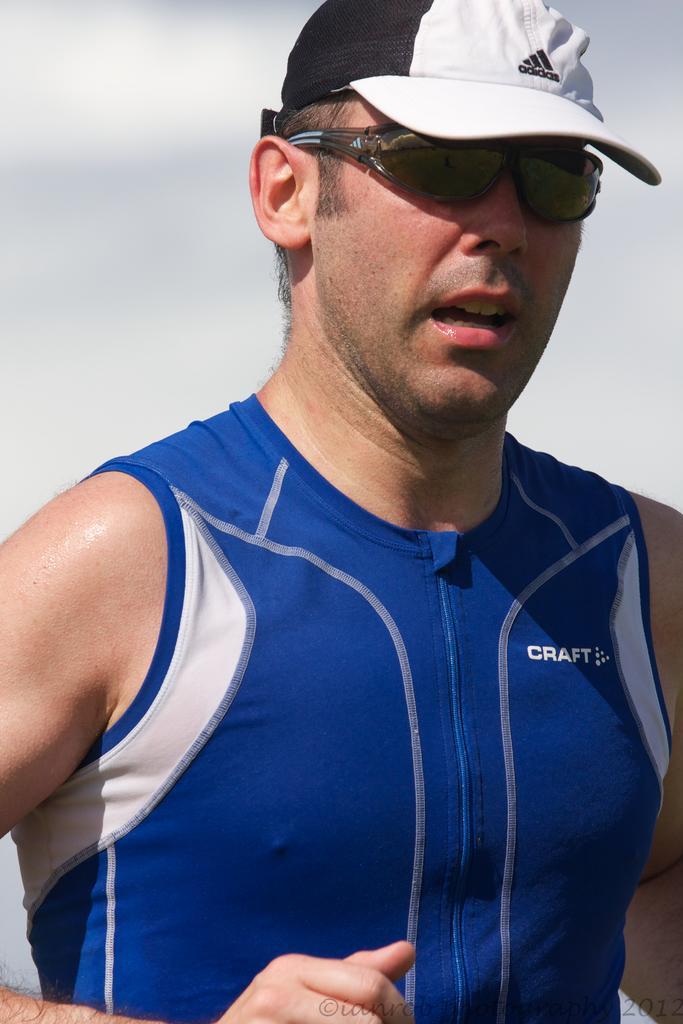Could you give a brief overview of what you see in this image? In the foreground of this image, there is a man in blue T shirt and a white and black cap and wearing spectacles. In the background image is blurred. 